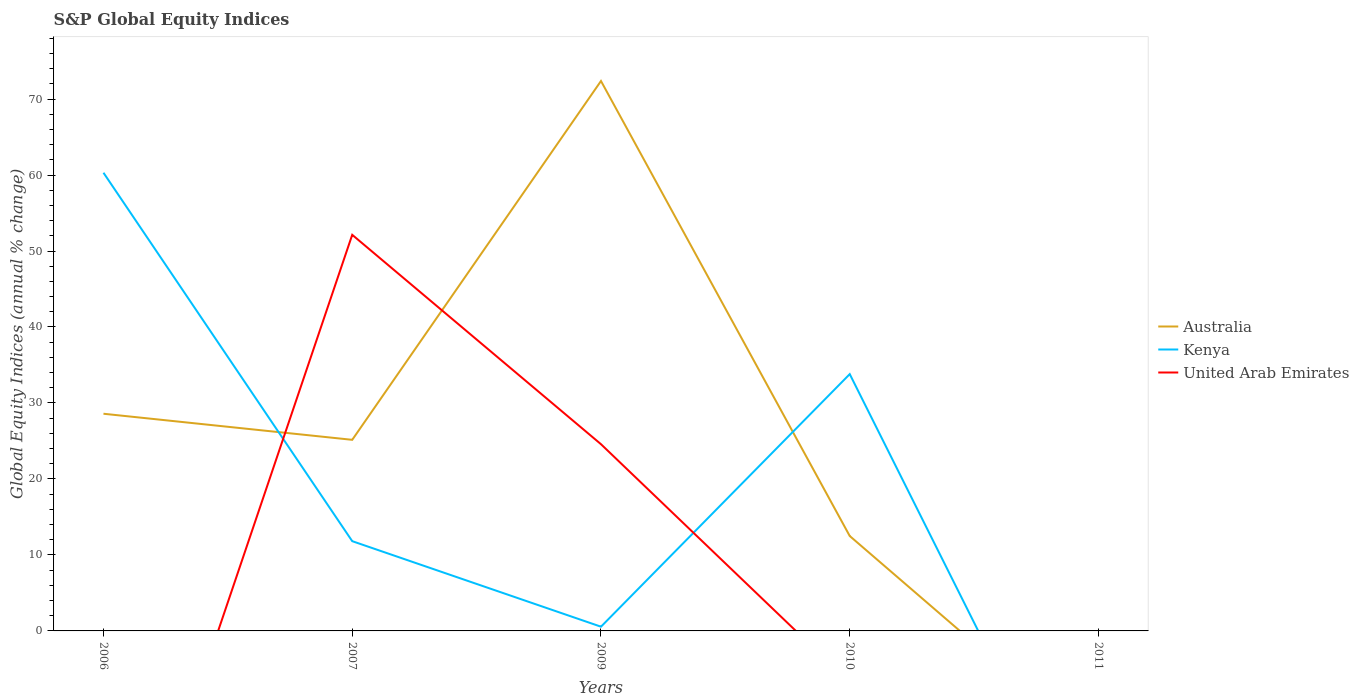How many different coloured lines are there?
Your answer should be compact. 3. Does the line corresponding to United Arab Emirates intersect with the line corresponding to Kenya?
Your answer should be compact. Yes. Is the number of lines equal to the number of legend labels?
Give a very brief answer. No. What is the total global equity indices in Kenya in the graph?
Keep it short and to the point. 11.26. What is the difference between the highest and the second highest global equity indices in United Arab Emirates?
Your answer should be very brief. 52.13. How many lines are there?
Make the answer very short. 3. How many years are there in the graph?
Offer a terse response. 5. Does the graph contain any zero values?
Provide a short and direct response. Yes. Does the graph contain grids?
Ensure brevity in your answer.  No. How many legend labels are there?
Offer a terse response. 3. What is the title of the graph?
Offer a very short reply. S&P Global Equity Indices. What is the label or title of the X-axis?
Your answer should be compact. Years. What is the label or title of the Y-axis?
Your answer should be compact. Global Equity Indices (annual % change). What is the Global Equity Indices (annual % change) in Australia in 2006?
Offer a terse response. 28.58. What is the Global Equity Indices (annual % change) in Kenya in 2006?
Offer a very short reply. 60.3. What is the Global Equity Indices (annual % change) of Australia in 2007?
Your answer should be compact. 25.15. What is the Global Equity Indices (annual % change) in Kenya in 2007?
Ensure brevity in your answer.  11.81. What is the Global Equity Indices (annual % change) of United Arab Emirates in 2007?
Your answer should be compact. 52.13. What is the Global Equity Indices (annual % change) in Australia in 2009?
Provide a short and direct response. 72.37. What is the Global Equity Indices (annual % change) of Kenya in 2009?
Give a very brief answer. 0.56. What is the Global Equity Indices (annual % change) of United Arab Emirates in 2009?
Your answer should be compact. 24.57. What is the Global Equity Indices (annual % change) in Australia in 2010?
Offer a terse response. 12.49. What is the Global Equity Indices (annual % change) in Kenya in 2010?
Provide a succinct answer. 33.8. What is the Global Equity Indices (annual % change) in United Arab Emirates in 2010?
Give a very brief answer. 0. What is the Global Equity Indices (annual % change) of Kenya in 2011?
Provide a short and direct response. 0. What is the Global Equity Indices (annual % change) in United Arab Emirates in 2011?
Provide a succinct answer. 0. Across all years, what is the maximum Global Equity Indices (annual % change) in Australia?
Your response must be concise. 72.37. Across all years, what is the maximum Global Equity Indices (annual % change) of Kenya?
Keep it short and to the point. 60.3. Across all years, what is the maximum Global Equity Indices (annual % change) in United Arab Emirates?
Offer a very short reply. 52.13. Across all years, what is the minimum Global Equity Indices (annual % change) of Australia?
Keep it short and to the point. 0. Across all years, what is the minimum Global Equity Indices (annual % change) of Kenya?
Make the answer very short. 0. What is the total Global Equity Indices (annual % change) in Australia in the graph?
Make the answer very short. 138.6. What is the total Global Equity Indices (annual % change) in Kenya in the graph?
Offer a very short reply. 106.47. What is the total Global Equity Indices (annual % change) of United Arab Emirates in the graph?
Ensure brevity in your answer.  76.71. What is the difference between the Global Equity Indices (annual % change) in Australia in 2006 and that in 2007?
Your answer should be very brief. 3.43. What is the difference between the Global Equity Indices (annual % change) of Kenya in 2006 and that in 2007?
Your answer should be compact. 48.49. What is the difference between the Global Equity Indices (annual % change) in Australia in 2006 and that in 2009?
Your response must be concise. -43.79. What is the difference between the Global Equity Indices (annual % change) in Kenya in 2006 and that in 2009?
Offer a terse response. 59.75. What is the difference between the Global Equity Indices (annual % change) of Australia in 2006 and that in 2010?
Keep it short and to the point. 16.09. What is the difference between the Global Equity Indices (annual % change) of Kenya in 2006 and that in 2010?
Offer a very short reply. 26.5. What is the difference between the Global Equity Indices (annual % change) in Australia in 2007 and that in 2009?
Your response must be concise. -47.22. What is the difference between the Global Equity Indices (annual % change) in Kenya in 2007 and that in 2009?
Offer a terse response. 11.26. What is the difference between the Global Equity Indices (annual % change) in United Arab Emirates in 2007 and that in 2009?
Provide a succinct answer. 27.56. What is the difference between the Global Equity Indices (annual % change) in Australia in 2007 and that in 2010?
Provide a succinct answer. 12.66. What is the difference between the Global Equity Indices (annual % change) of Kenya in 2007 and that in 2010?
Give a very brief answer. -21.99. What is the difference between the Global Equity Indices (annual % change) in Australia in 2009 and that in 2010?
Provide a succinct answer. 59.88. What is the difference between the Global Equity Indices (annual % change) in Kenya in 2009 and that in 2010?
Your answer should be compact. -33.24. What is the difference between the Global Equity Indices (annual % change) of Australia in 2006 and the Global Equity Indices (annual % change) of Kenya in 2007?
Make the answer very short. 16.77. What is the difference between the Global Equity Indices (annual % change) of Australia in 2006 and the Global Equity Indices (annual % change) of United Arab Emirates in 2007?
Make the answer very short. -23.55. What is the difference between the Global Equity Indices (annual % change) in Kenya in 2006 and the Global Equity Indices (annual % change) in United Arab Emirates in 2007?
Your answer should be very brief. 8.17. What is the difference between the Global Equity Indices (annual % change) of Australia in 2006 and the Global Equity Indices (annual % change) of Kenya in 2009?
Keep it short and to the point. 28.03. What is the difference between the Global Equity Indices (annual % change) of Australia in 2006 and the Global Equity Indices (annual % change) of United Arab Emirates in 2009?
Your answer should be compact. 4.01. What is the difference between the Global Equity Indices (annual % change) in Kenya in 2006 and the Global Equity Indices (annual % change) in United Arab Emirates in 2009?
Give a very brief answer. 35.73. What is the difference between the Global Equity Indices (annual % change) of Australia in 2006 and the Global Equity Indices (annual % change) of Kenya in 2010?
Offer a terse response. -5.22. What is the difference between the Global Equity Indices (annual % change) of Australia in 2007 and the Global Equity Indices (annual % change) of Kenya in 2009?
Your answer should be very brief. 24.59. What is the difference between the Global Equity Indices (annual % change) of Australia in 2007 and the Global Equity Indices (annual % change) of United Arab Emirates in 2009?
Make the answer very short. 0.58. What is the difference between the Global Equity Indices (annual % change) of Kenya in 2007 and the Global Equity Indices (annual % change) of United Arab Emirates in 2009?
Offer a terse response. -12.76. What is the difference between the Global Equity Indices (annual % change) in Australia in 2007 and the Global Equity Indices (annual % change) in Kenya in 2010?
Ensure brevity in your answer.  -8.65. What is the difference between the Global Equity Indices (annual % change) of Australia in 2009 and the Global Equity Indices (annual % change) of Kenya in 2010?
Give a very brief answer. 38.58. What is the average Global Equity Indices (annual % change) in Australia per year?
Ensure brevity in your answer.  27.72. What is the average Global Equity Indices (annual % change) of Kenya per year?
Provide a succinct answer. 21.29. What is the average Global Equity Indices (annual % change) in United Arab Emirates per year?
Your response must be concise. 15.34. In the year 2006, what is the difference between the Global Equity Indices (annual % change) of Australia and Global Equity Indices (annual % change) of Kenya?
Make the answer very short. -31.72. In the year 2007, what is the difference between the Global Equity Indices (annual % change) in Australia and Global Equity Indices (annual % change) in Kenya?
Give a very brief answer. 13.34. In the year 2007, what is the difference between the Global Equity Indices (annual % change) of Australia and Global Equity Indices (annual % change) of United Arab Emirates?
Ensure brevity in your answer.  -26.98. In the year 2007, what is the difference between the Global Equity Indices (annual % change) in Kenya and Global Equity Indices (annual % change) in United Arab Emirates?
Keep it short and to the point. -40.32. In the year 2009, what is the difference between the Global Equity Indices (annual % change) of Australia and Global Equity Indices (annual % change) of Kenya?
Provide a short and direct response. 71.82. In the year 2009, what is the difference between the Global Equity Indices (annual % change) of Australia and Global Equity Indices (annual % change) of United Arab Emirates?
Provide a succinct answer. 47.8. In the year 2009, what is the difference between the Global Equity Indices (annual % change) of Kenya and Global Equity Indices (annual % change) of United Arab Emirates?
Your answer should be very brief. -24.02. In the year 2010, what is the difference between the Global Equity Indices (annual % change) of Australia and Global Equity Indices (annual % change) of Kenya?
Provide a short and direct response. -21.31. What is the ratio of the Global Equity Indices (annual % change) of Australia in 2006 to that in 2007?
Offer a terse response. 1.14. What is the ratio of the Global Equity Indices (annual % change) of Kenya in 2006 to that in 2007?
Offer a terse response. 5.1. What is the ratio of the Global Equity Indices (annual % change) of Australia in 2006 to that in 2009?
Give a very brief answer. 0.39. What is the ratio of the Global Equity Indices (annual % change) of Kenya in 2006 to that in 2009?
Ensure brevity in your answer.  108.55. What is the ratio of the Global Equity Indices (annual % change) of Australia in 2006 to that in 2010?
Your answer should be compact. 2.29. What is the ratio of the Global Equity Indices (annual % change) of Kenya in 2006 to that in 2010?
Offer a very short reply. 1.78. What is the ratio of the Global Equity Indices (annual % change) of Australia in 2007 to that in 2009?
Your answer should be very brief. 0.35. What is the ratio of the Global Equity Indices (annual % change) in Kenya in 2007 to that in 2009?
Keep it short and to the point. 21.26. What is the ratio of the Global Equity Indices (annual % change) of United Arab Emirates in 2007 to that in 2009?
Your answer should be compact. 2.12. What is the ratio of the Global Equity Indices (annual % change) of Australia in 2007 to that in 2010?
Provide a succinct answer. 2.01. What is the ratio of the Global Equity Indices (annual % change) of Kenya in 2007 to that in 2010?
Provide a short and direct response. 0.35. What is the ratio of the Global Equity Indices (annual % change) in Australia in 2009 to that in 2010?
Your response must be concise. 5.79. What is the ratio of the Global Equity Indices (annual % change) in Kenya in 2009 to that in 2010?
Your answer should be very brief. 0.02. What is the difference between the highest and the second highest Global Equity Indices (annual % change) in Australia?
Offer a very short reply. 43.79. What is the difference between the highest and the second highest Global Equity Indices (annual % change) of Kenya?
Provide a short and direct response. 26.5. What is the difference between the highest and the lowest Global Equity Indices (annual % change) of Australia?
Your answer should be very brief. 72.37. What is the difference between the highest and the lowest Global Equity Indices (annual % change) in Kenya?
Give a very brief answer. 60.3. What is the difference between the highest and the lowest Global Equity Indices (annual % change) in United Arab Emirates?
Provide a succinct answer. 52.13. 